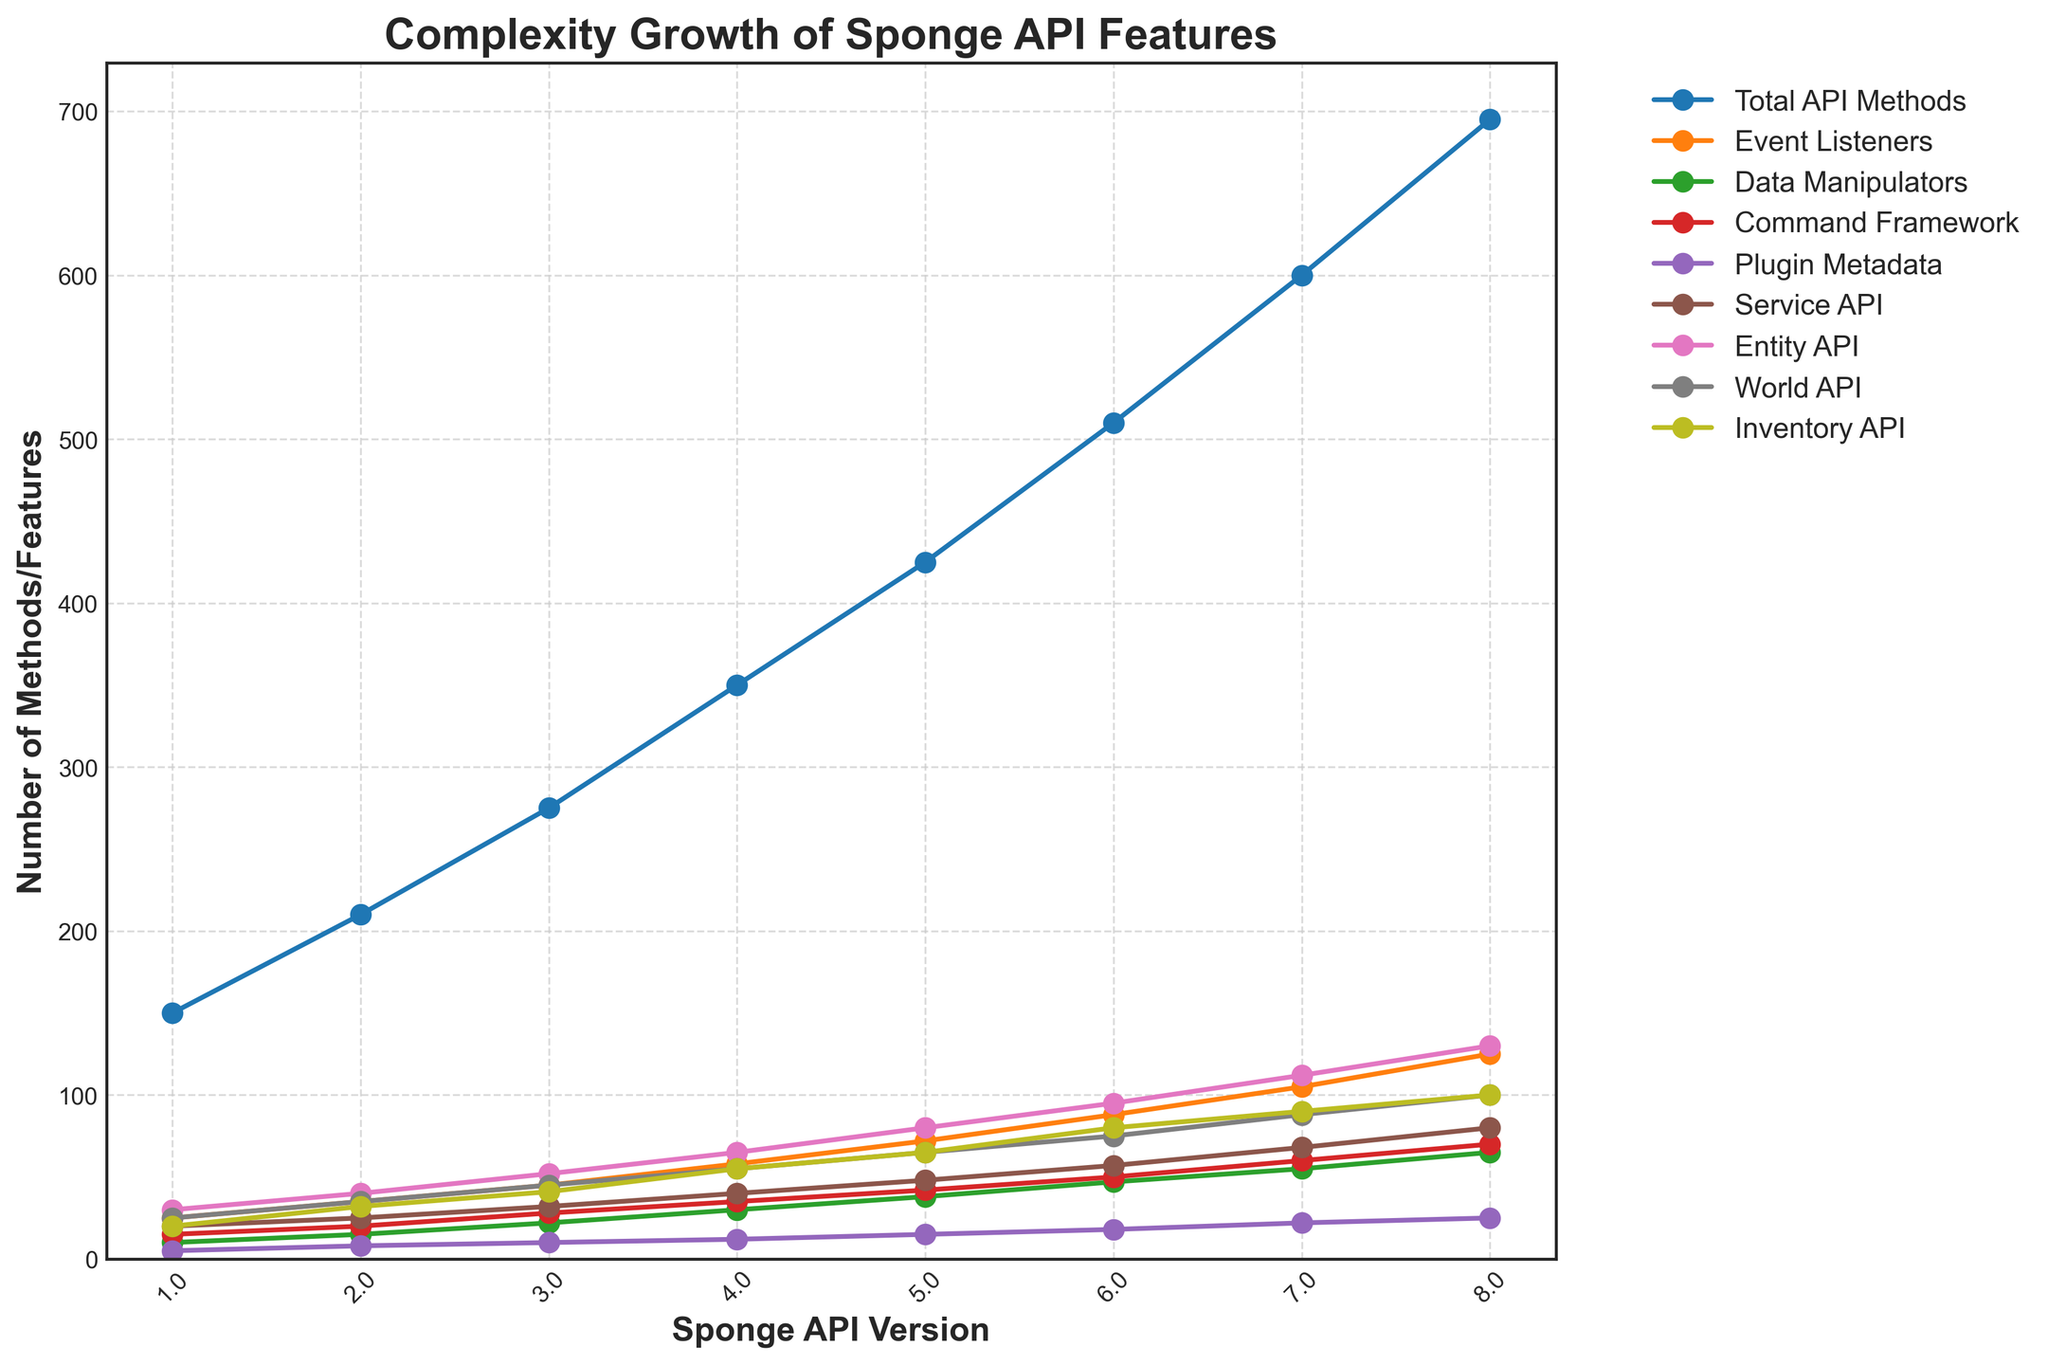What is the trend in the total number of API methods from version 1.0 to 8.0? To determine the trend, observe the line for "Total API Methods." Starting at 150 in version 1.0, it increases steadily through each version, reaching 695 by version 8.0.
Answer: Increasing Between which two consecutive versions did the Event Listeners grow the most? Compare the differences in the number of Event Listeners between each consecutive pair of versions. The largest growth occurs between version 7.0 (105) and version 8.0 (125), a difference of 20.
Answer: 7.0 and 8.0 How many methods were added in the Entity API from version 4.0 to version 6.0? To find the number of methods added, subtract the number of methods in version 4.0 from the number in version 6.0. Entity API methods are 65 in version 4.0 and 95 in version 6.0, so 95 - 65 = 30.
Answer: 30 Which version has the highest number of Data Manipulators? To determine this, look for the peak of the "Data Manipulators" line. The highest value, 65, occurs at version 8.0.
Answer: 8.0 Is there any version where the Command Framework’s growth decreased compared to the previous version? Observe the "Command Framework" line for any downward slopes between versions. All segments show an increase, meaning no decreases occurred.
Answer: No How does the number of Plugin Metadata methods compare at versions 3.0 and 5.0? Compare the values for "Plugin Metadata" at these versions. At version 3.0, it is 10, and at version 5.0, it is 15. Therefore, version 5.0 has more.
Answer: 5.0 has more Calculate the average number of Service API methods from version 1.0 to version 4.0. Add the number of Service API methods in versions 1.0 (20), 2.0 (25), 3.0 (32), and 4.0 (40) and divide by 4. Thus, (20 + 25 + 32 + 40) / 4 = 117 / 4 = 29.25.
Answer: 29.25 Which feature has the least number of methods in version 6.0? Look at the values for each feature in version 6.0. Plugin Metadata has the least, with 18 methods.
Answer: Plugin Metadata By how much did the Inventory API grow from version 5.0 to 8.0? Subtract the Inventory API value at version 5.0 from the value at version 8.0. The values are 65 and 100, respectively. So, 100 - 65 = 35.
Answer: 35 Among the given categories, which one shows the greatest overall increase in methods across all versions? Calculate the difference from version 1.0 to 8.0 for each category. The Total API Methods increased the most, from 150 to 695, resulting in an increase of 545.
Answer: Total API Methods 